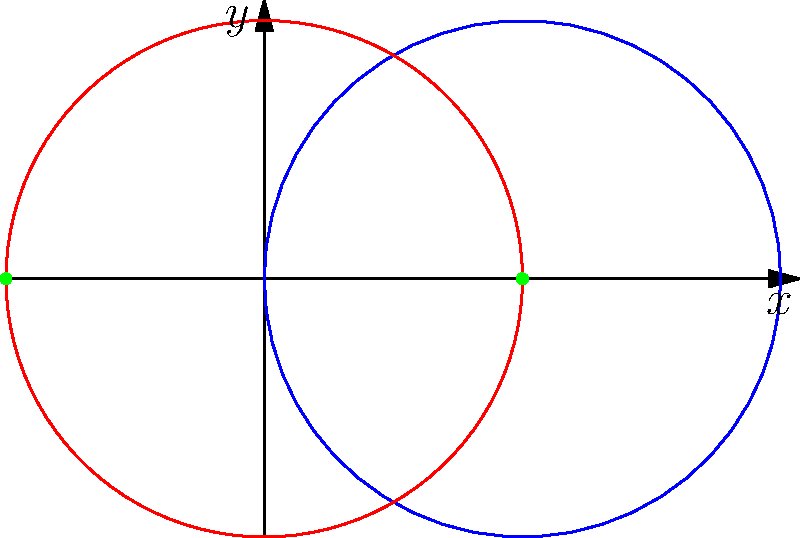For the polar curves $r = 2\cos(\theta)$ and $r = 1$, determine the $x$-coordinates of their intersection points. Express your answer in terms of fundamental mathematical constants. To find the intersection points, we need to solve the equation:

$$2\cos(\theta) = 1$$

1) Divide both sides by 2:
   $$\cos(\theta) = \frac{1}{2}$$

2) Recall that $\cos(\theta) = \frac{1}{2}$ occurs when $\theta = \pm \frac{\pi}{3}$ in the interval $[0, 2\pi]$.

3) Now, we need to convert these angles to Cartesian coordinates. In polar form, we have:
   $$(r, \theta) = (1, \frac{\pi}{3}) \text{ and } (1, -\frac{\pi}{3})$$

4) To convert to Cartesian coordinates, we use:
   $$x = r\cos(\theta)$$

5) For the first point:
   $$x_1 = 1 \cdot \cos(\frac{\pi}{3}) = \frac{1}{2}$$

6) For the second point:
   $$x_2 = 1 \cdot \cos(-\frac{\pi}{3}) = \frac{1}{2}$$

Therefore, both intersection points have the same x-coordinate: $\frac{1}{2}$.
Answer: $\{\frac{1}{2}, \frac{1}{2}\}$ 